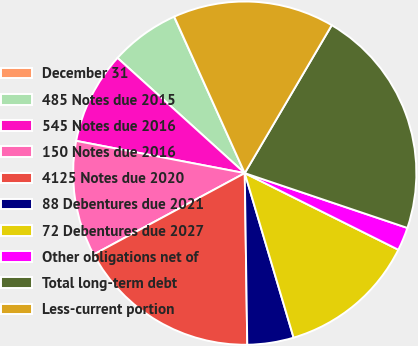Convert chart. <chart><loc_0><loc_0><loc_500><loc_500><pie_chart><fcel>December 31<fcel>485 Notes due 2015<fcel>545 Notes due 2016<fcel>150 Notes due 2016<fcel>4125 Notes due 2020<fcel>88 Debentures due 2021<fcel>72 Debentures due 2027<fcel>Other obligations net of<fcel>Total long-term debt<fcel>Less-current portion<nl><fcel>0.02%<fcel>6.53%<fcel>8.7%<fcel>10.87%<fcel>17.37%<fcel>4.36%<fcel>13.04%<fcel>2.19%<fcel>21.71%<fcel>15.2%<nl></chart> 